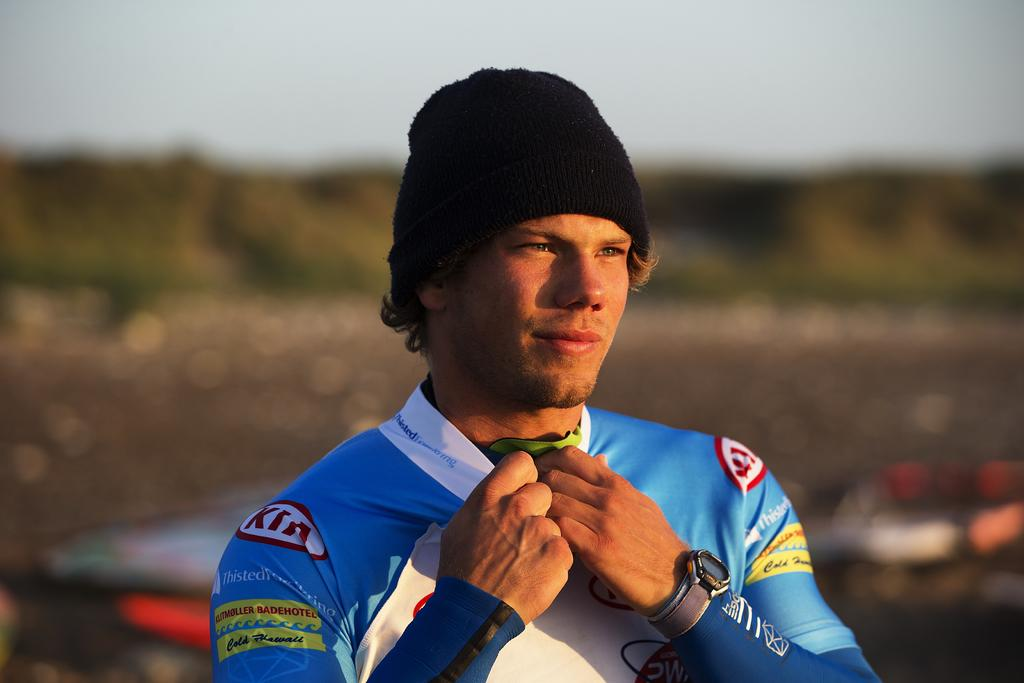Who is the main subject in the image? There is a man in the image. Can you describe the man's position in the image? The man is standing in the front. What is the man wearing on his head? The man is wearing a black cap. How would you describe the background of the image? The background of the image is blurred. How many legs does the acoustics have in the image? There is no acoustics present in the image, so it is not possible to determine how many legs it might have. 